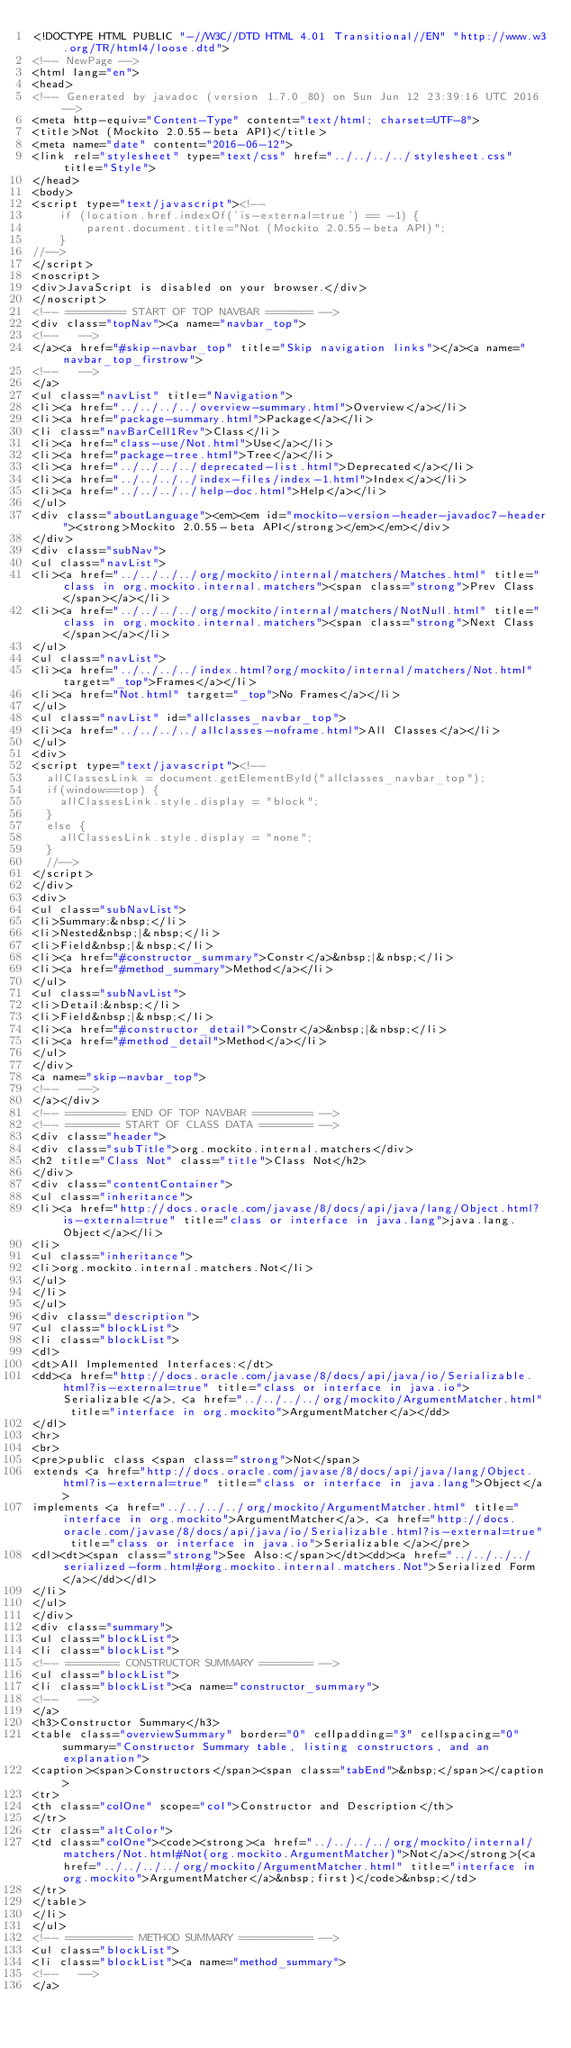Convert code to text. <code><loc_0><loc_0><loc_500><loc_500><_HTML_><!DOCTYPE HTML PUBLIC "-//W3C//DTD HTML 4.01 Transitional//EN" "http://www.w3.org/TR/html4/loose.dtd">
<!-- NewPage -->
<html lang="en">
<head>
<!-- Generated by javadoc (version 1.7.0_80) on Sun Jun 12 23:39:16 UTC 2016 -->
<meta http-equiv="Content-Type" content="text/html; charset=UTF-8">
<title>Not (Mockito 2.0.55-beta API)</title>
<meta name="date" content="2016-06-12">
<link rel="stylesheet" type="text/css" href="../../../../stylesheet.css" title="Style">
</head>
<body>
<script type="text/javascript"><!--
    if (location.href.indexOf('is-external=true') == -1) {
        parent.document.title="Not (Mockito 2.0.55-beta API)";
    }
//-->
</script>
<noscript>
<div>JavaScript is disabled on your browser.</div>
</noscript>
<!-- ========= START OF TOP NAVBAR ======= -->
<div class="topNav"><a name="navbar_top">
<!--   -->
</a><a href="#skip-navbar_top" title="Skip navigation links"></a><a name="navbar_top_firstrow">
<!--   -->
</a>
<ul class="navList" title="Navigation">
<li><a href="../../../../overview-summary.html">Overview</a></li>
<li><a href="package-summary.html">Package</a></li>
<li class="navBarCell1Rev">Class</li>
<li><a href="class-use/Not.html">Use</a></li>
<li><a href="package-tree.html">Tree</a></li>
<li><a href="../../../../deprecated-list.html">Deprecated</a></li>
<li><a href="../../../../index-files/index-1.html">Index</a></li>
<li><a href="../../../../help-doc.html">Help</a></li>
</ul>
<div class="aboutLanguage"><em><em id="mockito-version-header-javadoc7-header"><strong>Mockito 2.0.55-beta API</strong></em></em></div>
</div>
<div class="subNav">
<ul class="navList">
<li><a href="../../../../org/mockito/internal/matchers/Matches.html" title="class in org.mockito.internal.matchers"><span class="strong">Prev Class</span></a></li>
<li><a href="../../../../org/mockito/internal/matchers/NotNull.html" title="class in org.mockito.internal.matchers"><span class="strong">Next Class</span></a></li>
</ul>
<ul class="navList">
<li><a href="../../../../index.html?org/mockito/internal/matchers/Not.html" target="_top">Frames</a></li>
<li><a href="Not.html" target="_top">No Frames</a></li>
</ul>
<ul class="navList" id="allclasses_navbar_top">
<li><a href="../../../../allclasses-noframe.html">All Classes</a></li>
</ul>
<div>
<script type="text/javascript"><!--
  allClassesLink = document.getElementById("allclasses_navbar_top");
  if(window==top) {
    allClassesLink.style.display = "block";
  }
  else {
    allClassesLink.style.display = "none";
  }
  //-->
</script>
</div>
<div>
<ul class="subNavList">
<li>Summary:&nbsp;</li>
<li>Nested&nbsp;|&nbsp;</li>
<li>Field&nbsp;|&nbsp;</li>
<li><a href="#constructor_summary">Constr</a>&nbsp;|&nbsp;</li>
<li><a href="#method_summary">Method</a></li>
</ul>
<ul class="subNavList">
<li>Detail:&nbsp;</li>
<li>Field&nbsp;|&nbsp;</li>
<li><a href="#constructor_detail">Constr</a>&nbsp;|&nbsp;</li>
<li><a href="#method_detail">Method</a></li>
</ul>
</div>
<a name="skip-navbar_top">
<!--   -->
</a></div>
<!-- ========= END OF TOP NAVBAR ========= -->
<!-- ======== START OF CLASS DATA ======== -->
<div class="header">
<div class="subTitle">org.mockito.internal.matchers</div>
<h2 title="Class Not" class="title">Class Not</h2>
</div>
<div class="contentContainer">
<ul class="inheritance">
<li><a href="http://docs.oracle.com/javase/8/docs/api/java/lang/Object.html?is-external=true" title="class or interface in java.lang">java.lang.Object</a></li>
<li>
<ul class="inheritance">
<li>org.mockito.internal.matchers.Not</li>
</ul>
</li>
</ul>
<div class="description">
<ul class="blockList">
<li class="blockList">
<dl>
<dt>All Implemented Interfaces:</dt>
<dd><a href="http://docs.oracle.com/javase/8/docs/api/java/io/Serializable.html?is-external=true" title="class or interface in java.io">Serializable</a>, <a href="../../../../org/mockito/ArgumentMatcher.html" title="interface in org.mockito">ArgumentMatcher</a></dd>
</dl>
<hr>
<br>
<pre>public class <span class="strong">Not</span>
extends <a href="http://docs.oracle.com/javase/8/docs/api/java/lang/Object.html?is-external=true" title="class or interface in java.lang">Object</a>
implements <a href="../../../../org/mockito/ArgumentMatcher.html" title="interface in org.mockito">ArgumentMatcher</a>, <a href="http://docs.oracle.com/javase/8/docs/api/java/io/Serializable.html?is-external=true" title="class or interface in java.io">Serializable</a></pre>
<dl><dt><span class="strong">See Also:</span></dt><dd><a href="../../../../serialized-form.html#org.mockito.internal.matchers.Not">Serialized Form</a></dd></dl>
</li>
</ul>
</div>
<div class="summary">
<ul class="blockList">
<li class="blockList">
<!-- ======== CONSTRUCTOR SUMMARY ======== -->
<ul class="blockList">
<li class="blockList"><a name="constructor_summary">
<!--   -->
</a>
<h3>Constructor Summary</h3>
<table class="overviewSummary" border="0" cellpadding="3" cellspacing="0" summary="Constructor Summary table, listing constructors, and an explanation">
<caption><span>Constructors</span><span class="tabEnd">&nbsp;</span></caption>
<tr>
<th class="colOne" scope="col">Constructor and Description</th>
</tr>
<tr class="altColor">
<td class="colOne"><code><strong><a href="../../../../org/mockito/internal/matchers/Not.html#Not(org.mockito.ArgumentMatcher)">Not</a></strong>(<a href="../../../../org/mockito/ArgumentMatcher.html" title="interface in org.mockito">ArgumentMatcher</a>&nbsp;first)</code>&nbsp;</td>
</tr>
</table>
</li>
</ul>
<!-- ========== METHOD SUMMARY =========== -->
<ul class="blockList">
<li class="blockList"><a name="method_summary">
<!--   -->
</a></code> 